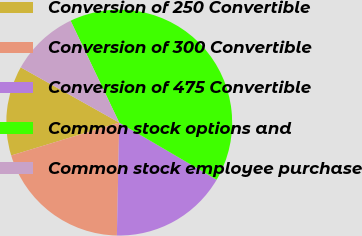Convert chart to OTSL. <chart><loc_0><loc_0><loc_500><loc_500><pie_chart><fcel>Conversion of 250 Convertible<fcel>Conversion of 300 Convertible<fcel>Conversion of 475 Convertible<fcel>Common stock options and<fcel>Common stock employee purchase<nl><fcel>12.84%<fcel>19.97%<fcel>16.9%<fcel>40.52%<fcel>9.77%<nl></chart> 